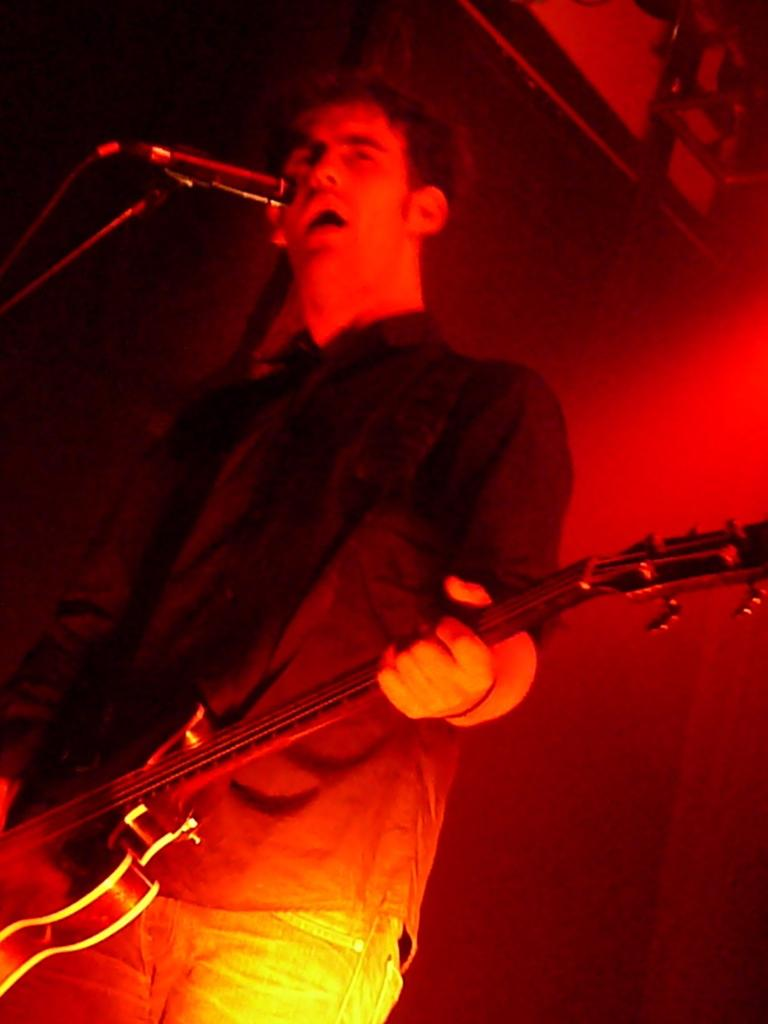What is the main subject in the foreground of the image? There is a man in the foreground of the image. What is the man holding in the image? The man is holding a guitar. What can be seen behind the man in the image? The man is standing in front of a mic stand. What color light is visible in the image? There is a red light visible in the image. What type of peace symbol can be seen on the cart in the image? There is no cart or peace symbol present in the image. 